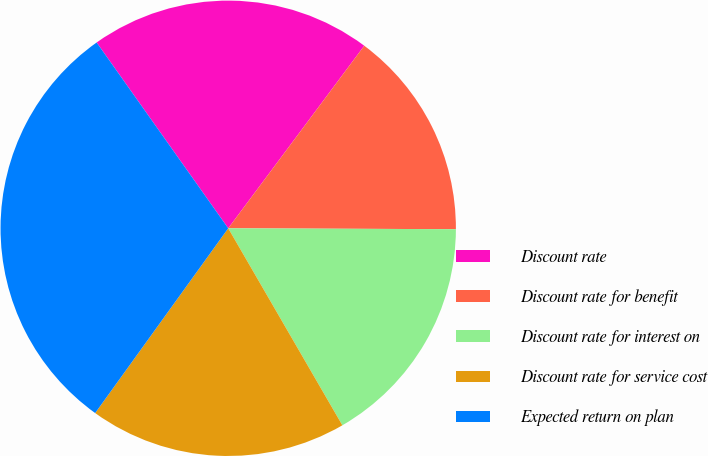<chart> <loc_0><loc_0><loc_500><loc_500><pie_chart><fcel>Discount rate<fcel>Discount rate for benefit<fcel>Discount rate for interest on<fcel>Discount rate for service cost<fcel>Expected return on plan<nl><fcel>20.0%<fcel>14.87%<fcel>16.58%<fcel>18.29%<fcel>30.26%<nl></chart> 